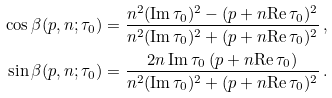Convert formula to latex. <formula><loc_0><loc_0><loc_500><loc_500>\cos \beta ( p , n ; \tau _ { 0 } ) & = \frac { n ^ { 2 } ( \text {Im} \, \tau _ { 0 } ) ^ { 2 } - ( p + n \text {Re} \, \tau _ { 0 } ) ^ { 2 } } { n ^ { 2 } ( \text {Im} \, \tau _ { 0 } ) ^ { 2 } + ( p + n \text {Re} \, \tau _ { 0 } ) ^ { 2 } } \, , \\ \sin \beta ( p , n ; \tau _ { 0 } ) & = \frac { 2 n \, \text {Im} \, \tau _ { 0 } \, ( p + n \text {Re} \, \tau _ { 0 } ) } { n ^ { 2 } ( \text {Im} \, \tau _ { 0 } ) ^ { 2 } + ( p + n \text {Re} \, \tau _ { 0 } ) ^ { 2 } } \, .</formula> 